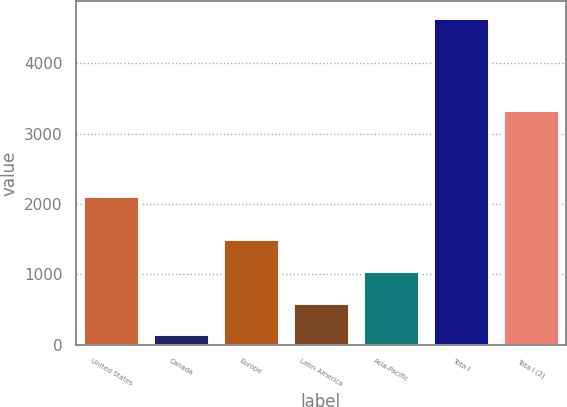Convert chart. <chart><loc_0><loc_0><loc_500><loc_500><bar_chart><fcel>United States<fcel>Canada<fcel>Europe<fcel>Latin America<fcel>Asia-Pacific<fcel>Tota l<fcel>Tota l (2)<nl><fcel>2118.2<fcel>147<fcel>1498.26<fcel>597.42<fcel>1047.84<fcel>4651.2<fcel>3339<nl></chart> 